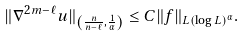Convert formula to latex. <formula><loc_0><loc_0><loc_500><loc_500>\| \nabla ^ { 2 m - \ell } u \| _ { \left ( \frac { n } { n - \ell } , \frac { 1 } { \alpha } \right ) } \leq C \| f \| _ { L ( \log L ) ^ { \alpha } } .</formula> 